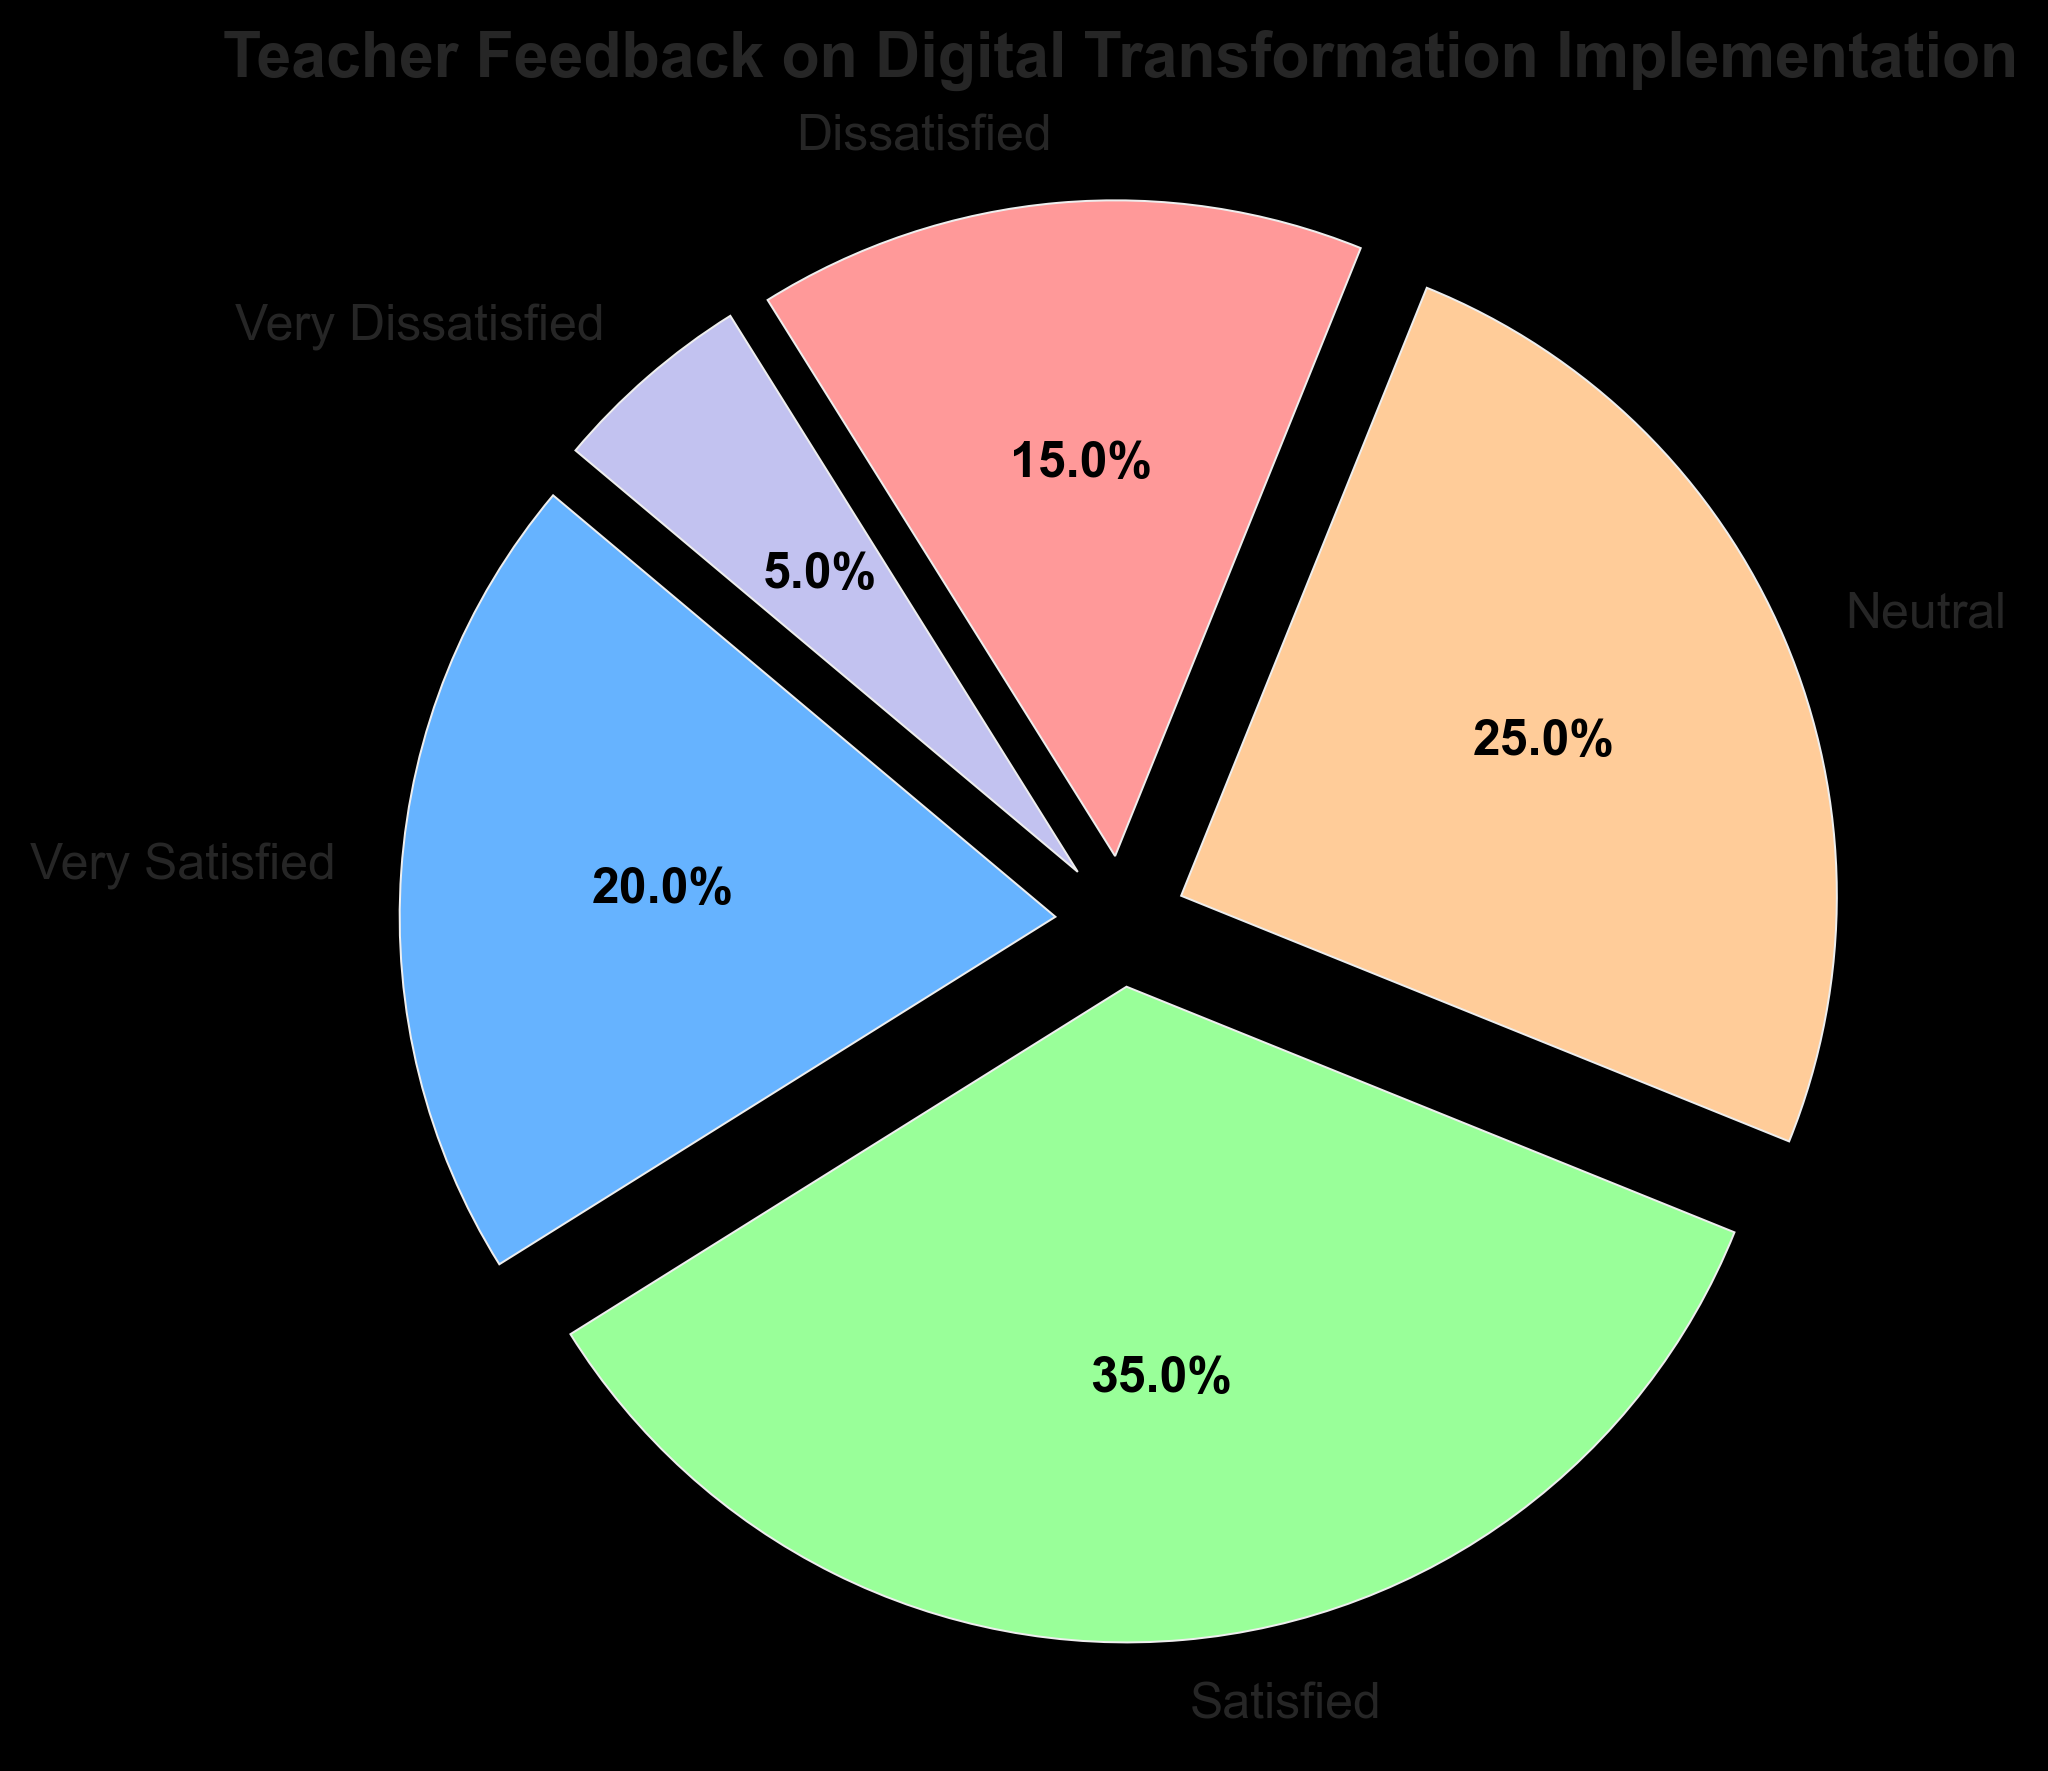What percentage of teachers are either very satisfied or satisfied with the digital transformation implementation? First, find the count of teachers who are very satisfied and satisfied, which are 20 and 35 respectively. Then, sum these counts to get 20 + 35 = 55. Finally, calculate the percentage based on the total number of teachers (20+35+25+15+5=100). The percentage is (55/100) * 100 = 55%.
Answer: 55% Which category has the least number of teachers? From the pie chart, the 'Very Dissatisfied' category has the smallest slice. According to the data, the count is 5.
Answer: Very Dissatisfied How many more teachers are satisfied compared to those who are neutral? Number of satisfied teachers is 35, and the number of neutral teachers is 25. To find the difference, subtract 25 from 35. The calculation is 35 - 25 = 10.
Answer: 10 What is the ratio of dissatisfied to very dissatisfied teachers? Number of dissatisfied teachers is 15 and very dissatisfied teachers is 5. The ratio is 15:5. Simplifying the ratio by dividing both numbers by 5 gives 3:1.
Answer: 3:1 What fraction of the total does the 'Neutral' category represent? The 'Neutral' category has 25 teachers out of the total 100. The fraction is 25/100 = 1/4.
Answer: 1/4 Identify the category with the largest share and state its percentage. From the pie chart, the 'Satisfied' category has the largest slice. According to the data, its count is 35. The percentage is (35/100) * 100 = 35%.
Answer: Satisfied, 35% Calculate the total number of teachers who are either dissatisfied or very dissatisfied. Number of dissatisfied teachers is 15 and very dissatisfied is 5. Sum these values: 15 + 5 = 20.
Answer: 20 What percentage of teachers are not satisfied (i.e., either neutral, dissatisfied, or very dissatisfied)? Sum the counts of 'Neutral', 'Dissatisfied', and 'Very Dissatisfied' which are 25, 15, and 5 respectively. Total is 25 + 15 + 5 = 45. Calculate the percentage: (45/100) * 100 = 45%.
Answer: 45% If the 'Neutral' category saw an increase of 5 teachers, what would their new percentage be? If 'Neutral' increases by 5, their count becomes 25 + 5 = 30. The total number of teachers also increases to 105. The new percentage of 'Neutral' is (30/105) * 100 = 28.6%.
Answer: 28.6% Compare the percentages of 'Very Satisfied' and 'Dissatisfied' categories. Which is higher and by how much? 'Very Satisfied' has 20% and 'Dissatisfied' has 15%. Calculate the difference: 20% - 15% = 5%. 'Very Satisfied' is higher by 5%.
Answer: Very Satisfied, 5% 